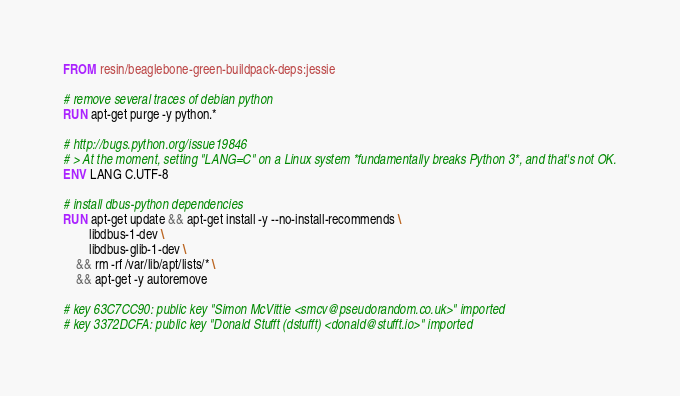Convert code to text. <code><loc_0><loc_0><loc_500><loc_500><_Dockerfile_>FROM resin/beaglebone-green-buildpack-deps:jessie

# remove several traces of debian python
RUN apt-get purge -y python.*

# http://bugs.python.org/issue19846
# > At the moment, setting "LANG=C" on a Linux system *fundamentally breaks Python 3*, and that's not OK.
ENV LANG C.UTF-8

# install dbus-python dependencies 
RUN apt-get update && apt-get install -y --no-install-recommends \
		libdbus-1-dev \
		libdbus-glib-1-dev \
	&& rm -rf /var/lib/apt/lists/* \
	&& apt-get -y autoremove

# key 63C7CC90: public key "Simon McVittie <smcv@pseudorandom.co.uk>" imported
# key 3372DCFA: public key "Donald Stufft (dstufft) <donald@stufft.io>" imported</code> 